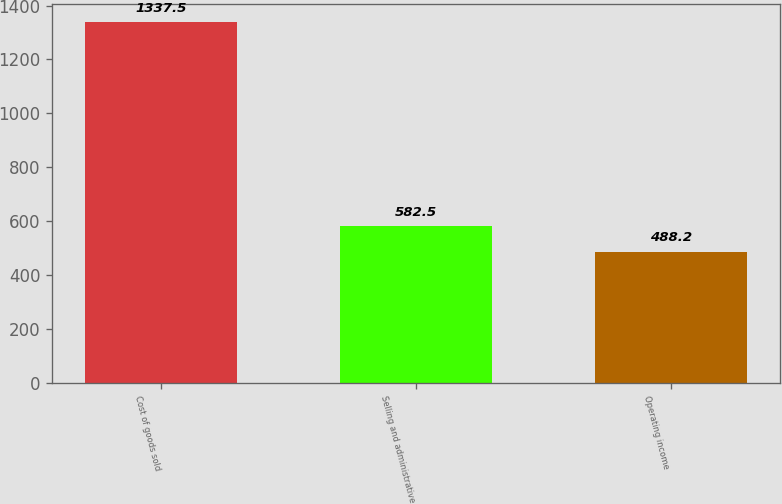<chart> <loc_0><loc_0><loc_500><loc_500><bar_chart><fcel>Cost of goods sold<fcel>Selling and administrative<fcel>Operating income<nl><fcel>1337.5<fcel>582.5<fcel>488.2<nl></chart> 